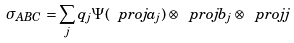<formula> <loc_0><loc_0><loc_500><loc_500>\sigma _ { A B C } = \sum _ { j } q _ { j } \Psi ( \ p r o j { a _ { j } } ) \otimes \ p r o j { b _ { j } } \otimes \ p r o j { j }</formula> 